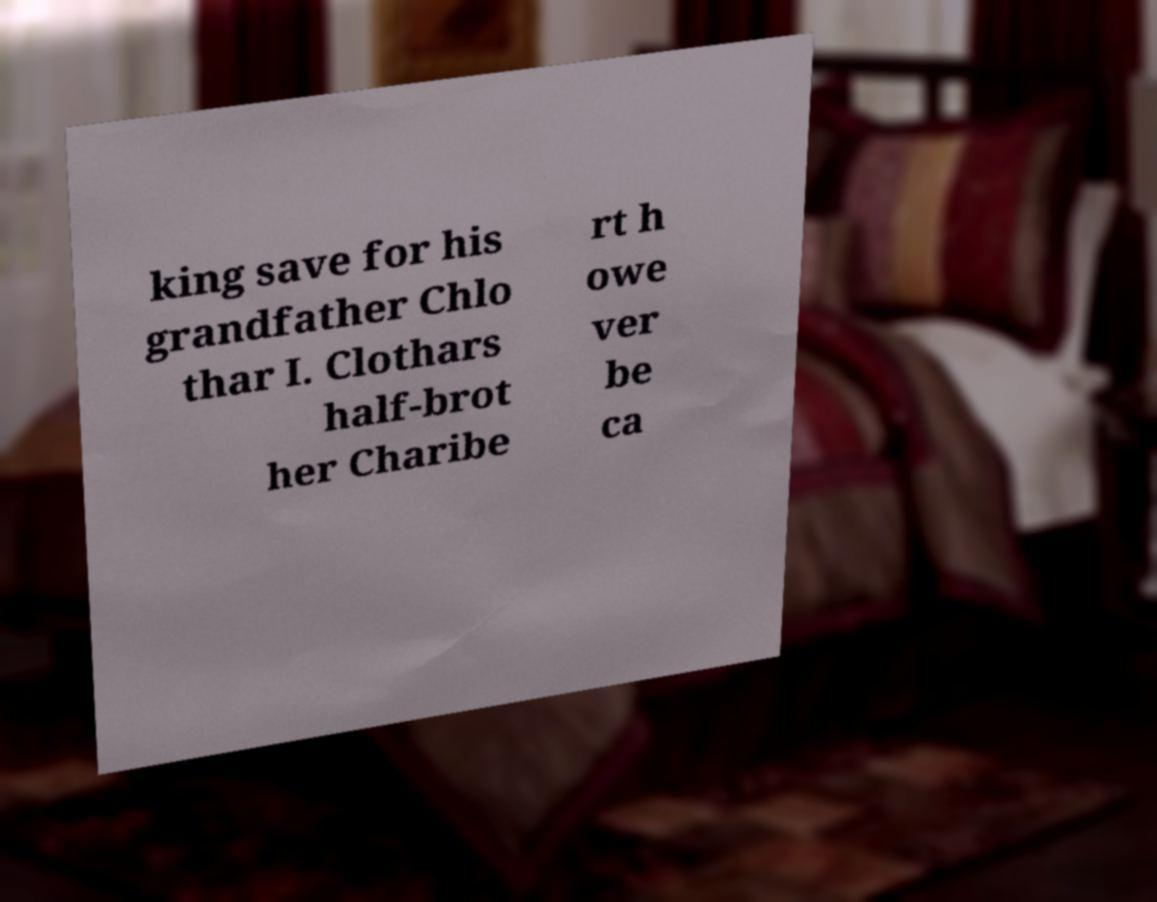What messages or text are displayed in this image? I need them in a readable, typed format. king save for his grandfather Chlo thar I. Clothars half-brot her Charibe rt h owe ver be ca 